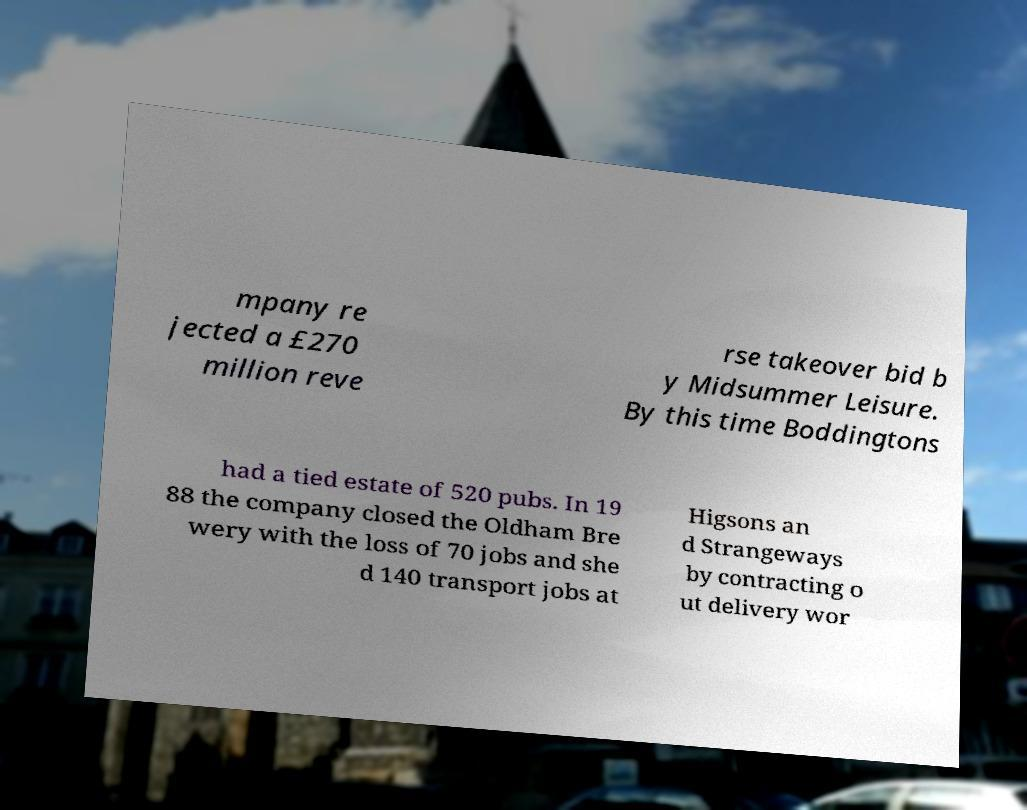For documentation purposes, I need the text within this image transcribed. Could you provide that? mpany re jected a £270 million reve rse takeover bid b y Midsummer Leisure. By this time Boddingtons had a tied estate of 520 pubs. In 19 88 the company closed the Oldham Bre wery with the loss of 70 jobs and she d 140 transport jobs at Higsons an d Strangeways by contracting o ut delivery wor 